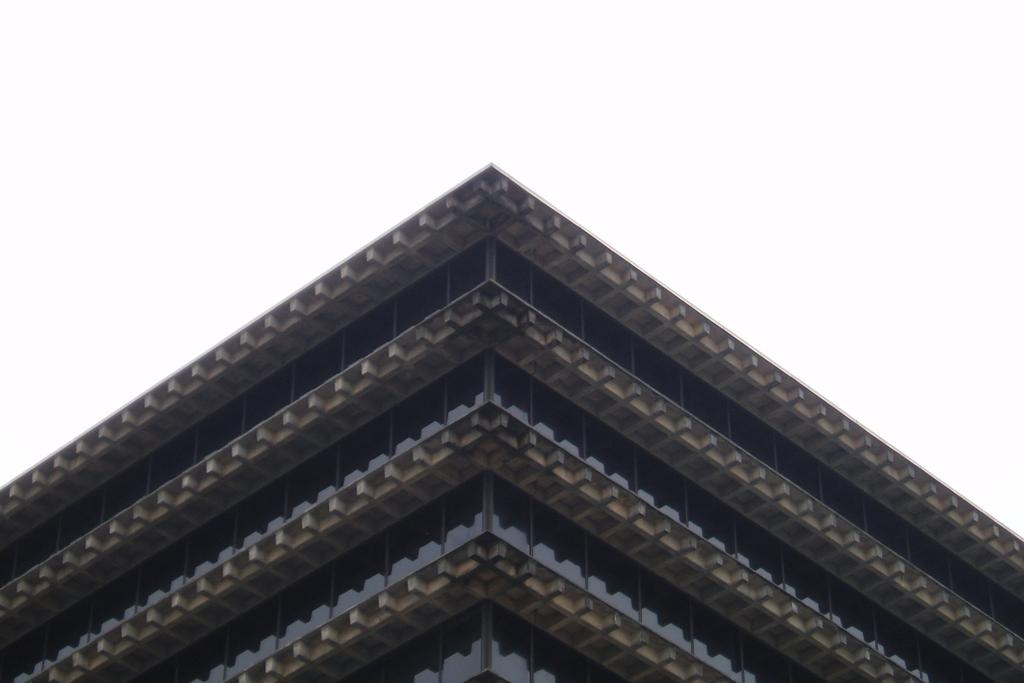What type of scene is depicted in the image? The image shows an outside view of a building. What can be seen in the background of the image? The sky is visible at the top of the image. What type of soda is being served at the game in the image? There is no game or soda present in the image; it only shows an outside view of a building with the sky visible in the background. 